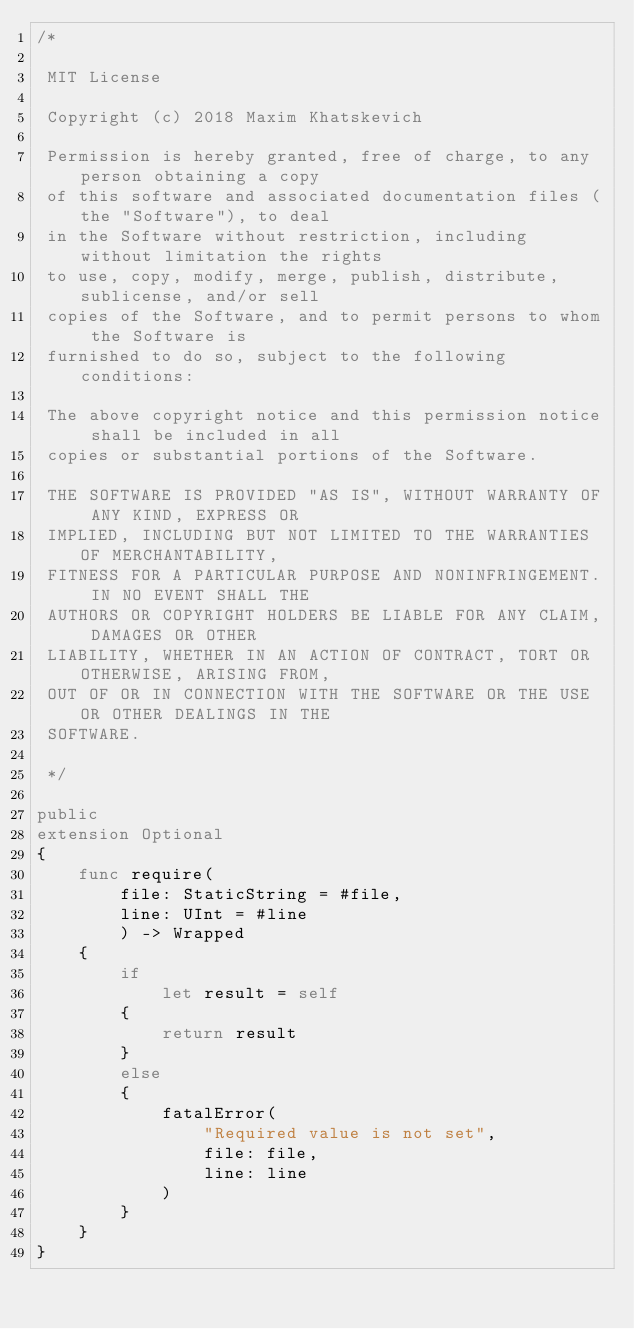<code> <loc_0><loc_0><loc_500><loc_500><_Swift_>/*
 
 MIT License
 
 Copyright (c) 2018 Maxim Khatskevich
 
 Permission is hereby granted, free of charge, to any person obtaining a copy
 of this software and associated documentation files (the "Software"), to deal
 in the Software without restriction, including without limitation the rights
 to use, copy, modify, merge, publish, distribute, sublicense, and/or sell
 copies of the Software, and to permit persons to whom the Software is
 furnished to do so, subject to the following conditions:
 
 The above copyright notice and this permission notice shall be included in all
 copies or substantial portions of the Software.
 
 THE SOFTWARE IS PROVIDED "AS IS", WITHOUT WARRANTY OF ANY KIND, EXPRESS OR
 IMPLIED, INCLUDING BUT NOT LIMITED TO THE WARRANTIES OF MERCHANTABILITY,
 FITNESS FOR A PARTICULAR PURPOSE AND NONINFRINGEMENT. IN NO EVENT SHALL THE
 AUTHORS OR COPYRIGHT HOLDERS BE LIABLE FOR ANY CLAIM, DAMAGES OR OTHER
 LIABILITY, WHETHER IN AN ACTION OF CONTRACT, TORT OR OTHERWISE, ARISING FROM,
 OUT OF OR IN CONNECTION WITH THE SOFTWARE OR THE USE OR OTHER DEALINGS IN THE
 SOFTWARE.
 
 */

public
extension Optional
{
    func require(
        file: StaticString = #file,
        line: UInt = #line
        ) -> Wrapped
    {
        if
            let result = self
        {
            return result
        }
        else
        {
            fatalError(
                "Required value is not set",
                file: file,
                line: line
            )
        }
    }
}
</code> 